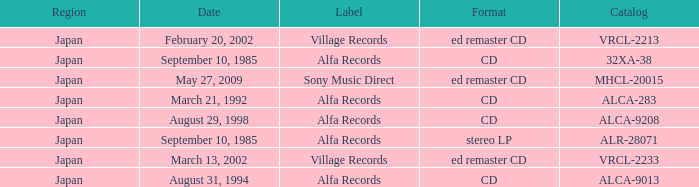Which Label was cataloged as alca-9013? Alfa Records. 